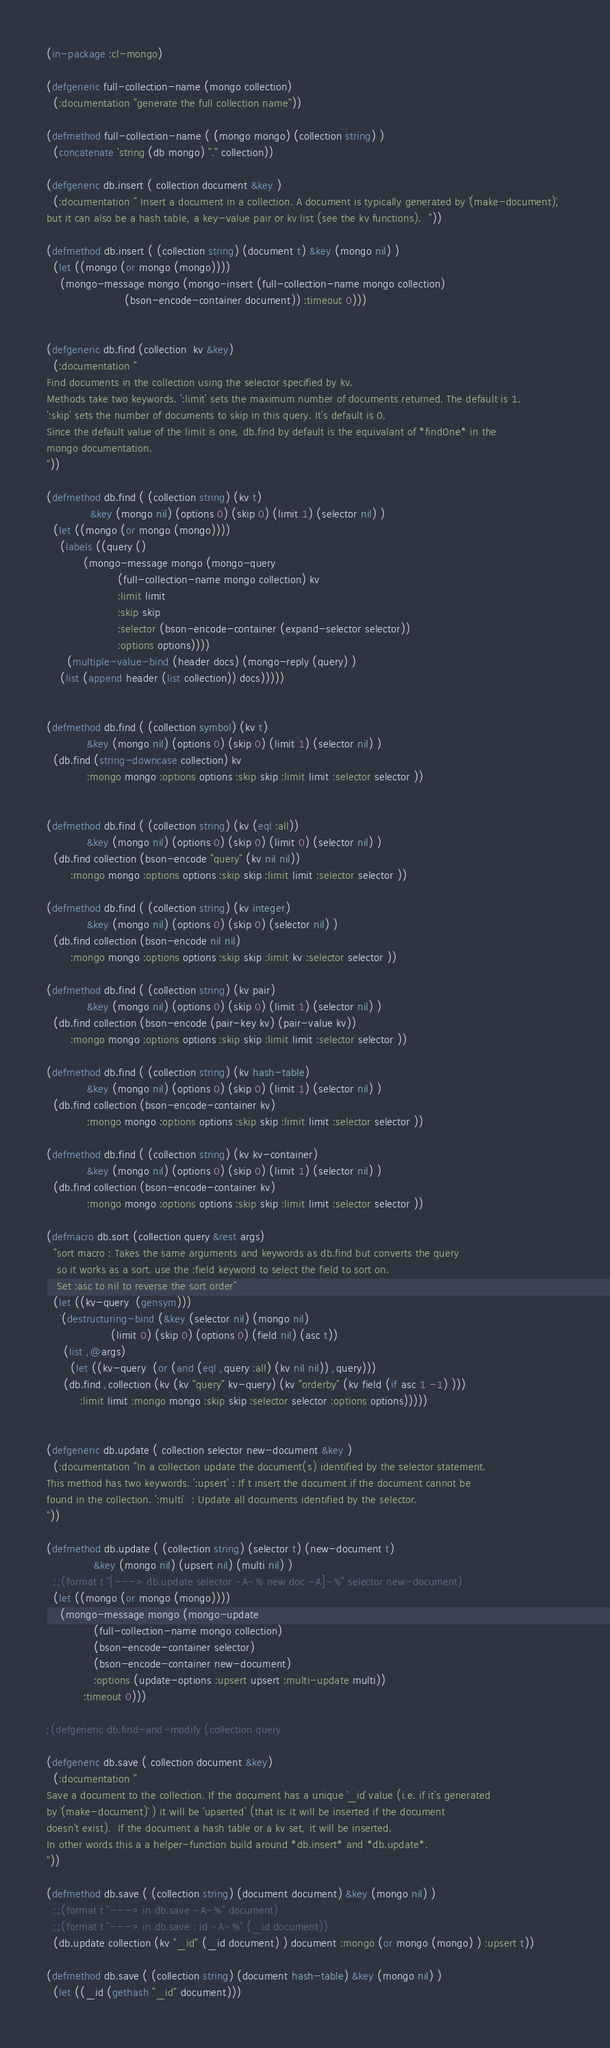<code> <loc_0><loc_0><loc_500><loc_500><_Lisp_>(in-package :cl-mongo)

(defgeneric full-collection-name (mongo collection)
  (:documentation "generate the full collection name"))

(defmethod full-collection-name ( (mongo mongo) (collection string) )
  (concatenate 'string (db mongo) "." collection))

(defgeneric db.insert ( collection document &key )
  (:documentation " Insert a document in a collection. A document is typically generated by `(make-document)`, 
but it can also be a hash table, a key-value pair or kv list (see the kv functions).  "))

(defmethod db.insert ( (collection string) (document t) &key (mongo nil) )
  (let ((mongo (or mongo (mongo))))
    (mongo-message mongo (mongo-insert (full-collection-name mongo collection) 
				       (bson-encode-container document)) :timeout 0)))


(defgeneric db.find (collection  kv &key)
  (:documentation "
Find documents in the collection using the selector specified by kv.  
Methods take two keywords. ':limit' sets the maximum number of documents returned. The default is 1.
':skip' sets the number of documents to skip in this query. It's default is 0.
Since the default value of the limit is one, db.find by default is the equivalant of *findOne* in the
mongo documentation.
"))

(defmethod db.find ( (collection string) (kv t) 
			 &key (mongo nil) (options 0) (skip 0) (limit 1) (selector nil) )
  (let ((mongo (or mongo (mongo))))
    (labels ((query ()
	       (mongo-message mongo (mongo-query 
				     (full-collection-name mongo collection) kv
				     :limit limit 
				     :skip skip 
				     :selector (bson-encode-container (expand-selector selector))
				     :options options))))
      (multiple-value-bind (header docs) (mongo-reply (query) )
	(list (append header (list collection)) docs)))))


(defmethod db.find ( (collection symbol) (kv t) 
		    &key (mongo nil) (options 0) (skip 0) (limit 1) (selector nil) )
  (db.find (string-downcase collection) kv 
		    :mongo mongo :options options :skip skip :limit limit :selector selector ))


(defmethod db.find ( (collection string) (kv (eql :all)) 
		    &key (mongo nil) (options 0) (skip 0) (limit 0) (selector nil) )
  (db.find collection (bson-encode "query" (kv nil nil))
	   :mongo mongo :options options :skip skip :limit limit :selector selector ))
  
(defmethod db.find ( (collection string) (kv integer) 
		    &key (mongo nil) (options 0) (skip 0) (selector nil) )
  (db.find collection (bson-encode nil nil)
	   :mongo mongo :options options :skip skip :limit kv :selector selector ))

(defmethod db.find ( (collection string) (kv pair) 
		    &key (mongo nil) (options 0) (skip 0) (limit 1) (selector nil) )
  (db.find collection (bson-encode (pair-key kv) (pair-value kv))
	   :mongo mongo :options options :skip skip :limit limit :selector selector ))

(defmethod db.find ( (collection string) (kv hash-table) 
		    &key (mongo nil) (options 0) (skip 0) (limit 1) (selector nil) )
  (db.find collection (bson-encode-container kv)
		    :mongo mongo :options options :skip skip :limit limit :selector selector ))

(defmethod db.find ( (collection string) (kv kv-container) 
		    &key (mongo nil) (options 0) (skip 0) (limit 1) (selector nil) )
  (db.find collection (bson-encode-container kv)
		    :mongo mongo :options options :skip skip :limit limit :selector selector ))

(defmacro db.sort (collection query &rest args) 
  "sort macro : Takes the same arguments and keywords as db.find but converts the query 
   so it works as a sort. use the :field keyword to select the field to sort on.
   Set :asc to nil to reverse the sort order"
  (let ((kv-query  (gensym)))
    `(destructuring-bind (&key (selector nil) (mongo nil) 
			       (limit 0) (skip 0) (options 0) (field nil) (asc t))
	 (list ,@args)
       (let ((kv-query  (or (and (eql ,query :all) (kv nil nil)) ,query)))
	 (db.find ,collection (kv (kv "query" kv-query) (kv "orderby" (kv field (if asc 1 -1) )))
		  :limit limit :mongo mongo :skip skip :selector selector :options options)))))


(defgeneric db.update ( collection selector new-document &key )
  (:documentation "In a collection update the document(s) identified by the selector statement.  
This method has two keywords. ':upsert' : If t insert the document if the document cannot be 
found in the collection. ':multi'  : Update all documents identified by the selector.
"))

(defmethod db.update ( (collection string) (selector t) (new-document t) 
		      &key (mongo nil) (upsert nil) (multi nil) )
  ;;(format t "[---> db.update selector ~A~% new doc ~A]~%" selector new-document)
  (let ((mongo (or mongo (mongo))))
    (mongo-message mongo (mongo-update 
			  (full-collection-name mongo collection) 
			  (bson-encode-container selector) 
			  (bson-encode-container new-document) 
			  :options (update-options :upsert upsert :multi-update multi))
		   :timeout 0)))

;(defgeneric db.find-and-modify (collection query 

(defgeneric db.save ( collection document &key) 
  (:documentation "
Save a document to the collection. If the document has a unique `_id` value (i.e. if it's generated
by `(make-document)` ) it will be 'upserted' (that is: it will be inserted if the document
doesn't exist).  If the document a hash table or a kv set, it will be inserted.  
In other words this a a helper-function build around *db.insert* and *db.update*.
"))

(defmethod db.save ( (collection string) (document document) &key (mongo nil) )
  ;;(format t "---> in db.save ~A~%" document)
  ;;(format t "---> in db.save : id ~A~%" (_id document))
  (db.update collection (kv "_id" (_id document) ) document :mongo (or mongo (mongo) ) :upsert t))

(defmethod db.save ( (collection string) (document hash-table) &key (mongo nil) )
  (let ((_id (gethash "_id" document)))</code> 